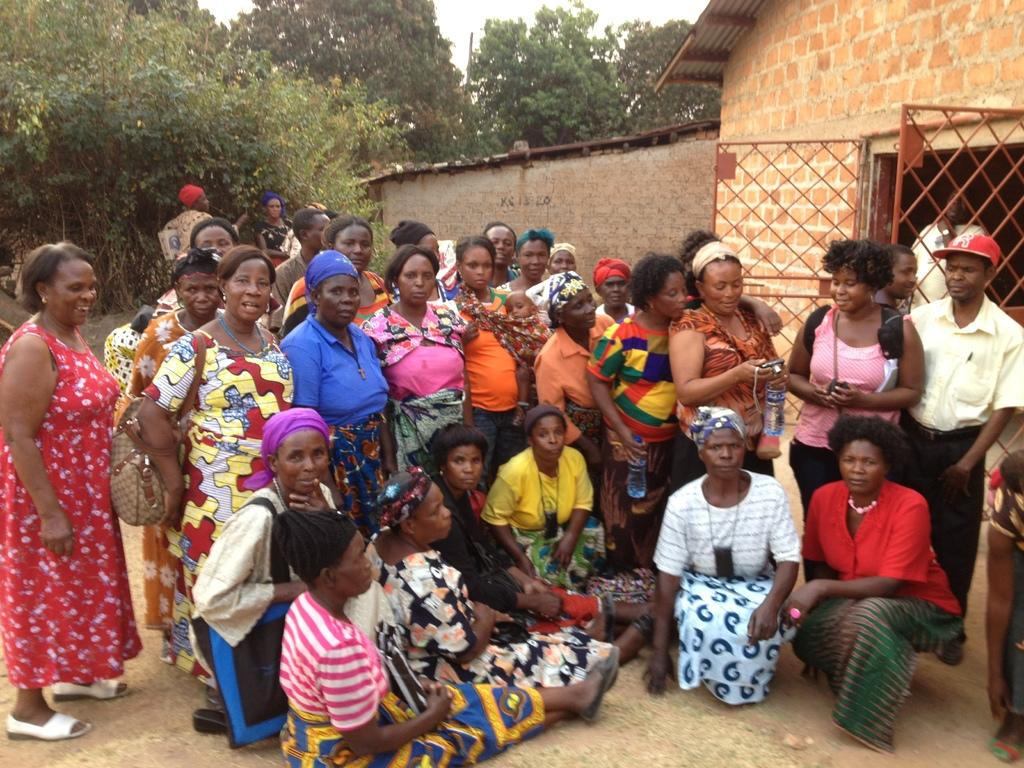What are the people in the image doing? Some people are standing, and others are sitting in the image. What structure can be seen on the right side of the image? There is a house on the right side of the image. What type of natural environment is visible in the background of the image? Trees are present in the background of the image. What type of elbow can be seen in the image? There is no elbow present in the image. What type of spoon is being used by the people in the image? There is no spoon visible in the image. 